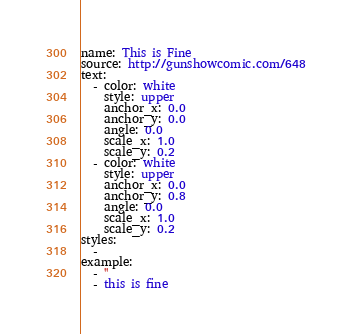<code> <loc_0><loc_0><loc_500><loc_500><_YAML_>name: This is Fine
source: http://gunshowcomic.com/648
text:
  - color: white
    style: upper
    anchor_x: 0.0
    anchor_y: 0.0
    angle: 0.0
    scale_x: 1.0
    scale_y: 0.2
  - color: white
    style: upper
    anchor_x: 0.0
    anchor_y: 0.8
    angle: 0.0
    scale_x: 1.0
    scale_y: 0.2
styles:
  -
example:
  - ''
  - this is fine
</code> 